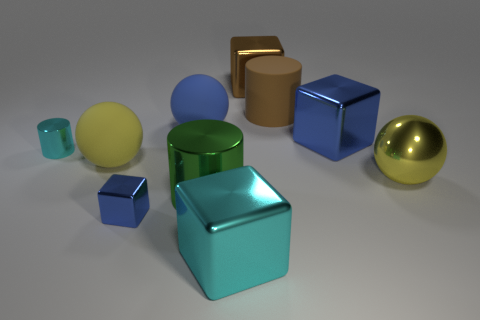Can you guess what the time of day might be based on the lighting in this image? Based on the soft shadows and the even distribution of light, it's difficult to infer an exact time of day; however, the lighting setup seems artificial, akin to studio lighting, rather than natural sunlight. 